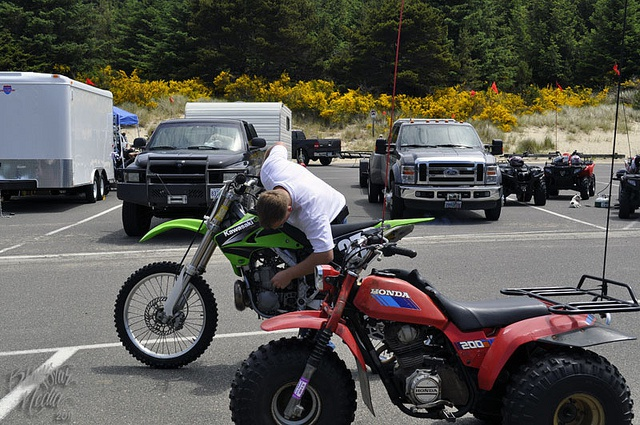Describe the objects in this image and their specific colors. I can see motorcycle in black, darkgray, gray, and maroon tones, motorcycle in black, darkgray, gray, and darkgreen tones, truck in black, darkgray, gray, and lightgray tones, truck in black, gray, and darkgray tones, and truck in black, darkgray, gray, and lightgray tones in this image. 